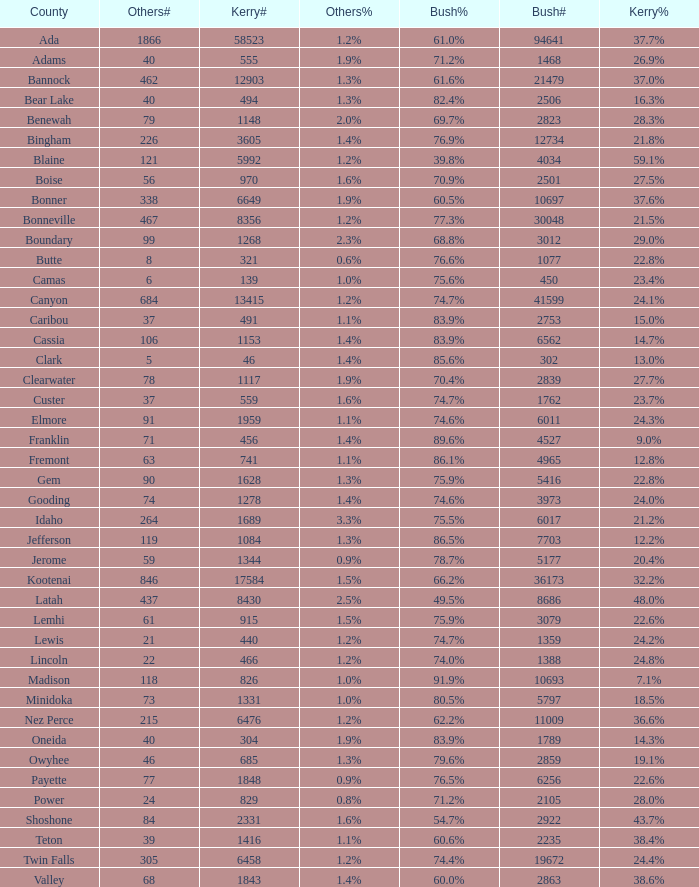What percentage of the votes were for others in the county where 462 people voted that way? 1.3%. 